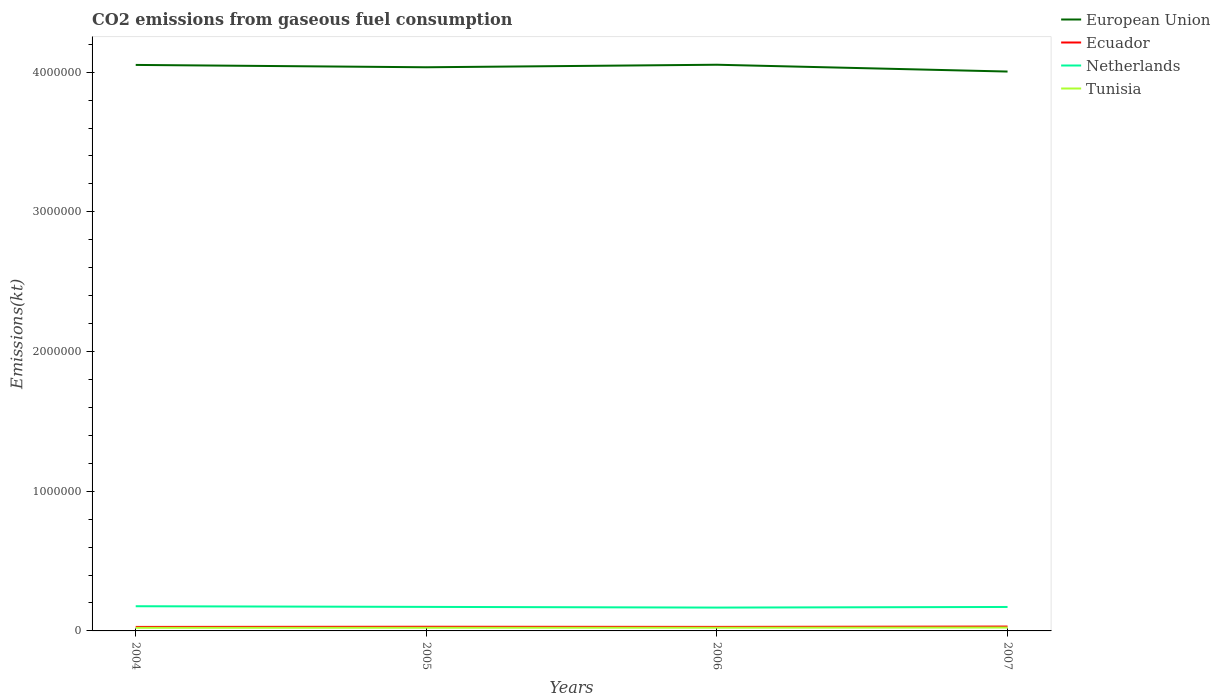How many different coloured lines are there?
Offer a terse response. 4. Across all years, what is the maximum amount of CO2 emitted in Netherlands?
Your answer should be compact. 1.67e+05. In which year was the amount of CO2 emitted in European Union maximum?
Your answer should be compact. 2007. What is the total amount of CO2 emitted in European Union in the graph?
Ensure brevity in your answer.  -1.81e+04. What is the difference between the highest and the second highest amount of CO2 emitted in Ecuador?
Make the answer very short. 2651.24. How many lines are there?
Keep it short and to the point. 4. How many years are there in the graph?
Provide a succinct answer. 4. What is the difference between two consecutive major ticks on the Y-axis?
Offer a very short reply. 1.00e+06. Where does the legend appear in the graph?
Ensure brevity in your answer.  Top right. How many legend labels are there?
Your response must be concise. 4. How are the legend labels stacked?
Keep it short and to the point. Vertical. What is the title of the graph?
Offer a terse response. CO2 emissions from gaseous fuel consumption. What is the label or title of the X-axis?
Keep it short and to the point. Years. What is the label or title of the Y-axis?
Keep it short and to the point. Emissions(kt). What is the Emissions(kt) in European Union in 2004?
Offer a terse response. 4.05e+06. What is the Emissions(kt) of Ecuador in 2004?
Offer a very short reply. 2.87e+04. What is the Emissions(kt) in Netherlands in 2004?
Offer a very short reply. 1.77e+05. What is the Emissions(kt) in Tunisia in 2004?
Your response must be concise. 2.23e+04. What is the Emissions(kt) in European Union in 2005?
Provide a succinct answer. 4.03e+06. What is the Emissions(kt) of Ecuador in 2005?
Offer a terse response. 2.99e+04. What is the Emissions(kt) in Netherlands in 2005?
Your answer should be very brief. 1.72e+05. What is the Emissions(kt) of Tunisia in 2005?
Your answer should be compact. 2.27e+04. What is the Emissions(kt) of European Union in 2006?
Your answer should be compact. 4.05e+06. What is the Emissions(kt) of Ecuador in 2006?
Provide a succinct answer. 2.89e+04. What is the Emissions(kt) of Netherlands in 2006?
Ensure brevity in your answer.  1.67e+05. What is the Emissions(kt) of Tunisia in 2006?
Make the answer very short. 2.30e+04. What is the Emissions(kt) in European Union in 2007?
Keep it short and to the point. 4.00e+06. What is the Emissions(kt) of Ecuador in 2007?
Provide a succinct answer. 3.13e+04. What is the Emissions(kt) in Netherlands in 2007?
Give a very brief answer. 1.71e+05. What is the Emissions(kt) in Tunisia in 2007?
Make the answer very short. 2.41e+04. Across all years, what is the maximum Emissions(kt) of European Union?
Provide a short and direct response. 4.05e+06. Across all years, what is the maximum Emissions(kt) of Ecuador?
Your answer should be compact. 3.13e+04. Across all years, what is the maximum Emissions(kt) of Netherlands?
Ensure brevity in your answer.  1.77e+05. Across all years, what is the maximum Emissions(kt) of Tunisia?
Ensure brevity in your answer.  2.41e+04. Across all years, what is the minimum Emissions(kt) of European Union?
Keep it short and to the point. 4.00e+06. Across all years, what is the minimum Emissions(kt) in Ecuador?
Offer a terse response. 2.87e+04. Across all years, what is the minimum Emissions(kt) of Netherlands?
Your answer should be compact. 1.67e+05. Across all years, what is the minimum Emissions(kt) of Tunisia?
Make the answer very short. 2.23e+04. What is the total Emissions(kt) of European Union in the graph?
Your answer should be very brief. 1.61e+07. What is the total Emissions(kt) in Ecuador in the graph?
Keep it short and to the point. 1.19e+05. What is the total Emissions(kt) in Netherlands in the graph?
Your response must be concise. 6.87e+05. What is the total Emissions(kt) in Tunisia in the graph?
Your response must be concise. 9.21e+04. What is the difference between the Emissions(kt) in European Union in 2004 and that in 2005?
Offer a terse response. 1.68e+04. What is the difference between the Emissions(kt) in Ecuador in 2004 and that in 2005?
Provide a short and direct response. -1250.45. What is the difference between the Emissions(kt) of Netherlands in 2004 and that in 2005?
Provide a succinct answer. 4668.09. What is the difference between the Emissions(kt) in Tunisia in 2004 and that in 2005?
Provide a succinct answer. -363.03. What is the difference between the Emissions(kt) in European Union in 2004 and that in 2006?
Ensure brevity in your answer.  -1342.12. What is the difference between the Emissions(kt) of Ecuador in 2004 and that in 2006?
Make the answer very short. -201.69. What is the difference between the Emissions(kt) in Netherlands in 2004 and that in 2006?
Provide a succinct answer. 9581.87. What is the difference between the Emissions(kt) in Tunisia in 2004 and that in 2006?
Give a very brief answer. -693.06. What is the difference between the Emissions(kt) in European Union in 2004 and that in 2007?
Provide a succinct answer. 4.74e+04. What is the difference between the Emissions(kt) in Ecuador in 2004 and that in 2007?
Keep it short and to the point. -2651.24. What is the difference between the Emissions(kt) of Netherlands in 2004 and that in 2007?
Give a very brief answer. 5199.81. What is the difference between the Emissions(kt) of Tunisia in 2004 and that in 2007?
Make the answer very short. -1811.5. What is the difference between the Emissions(kt) in European Union in 2005 and that in 2006?
Offer a terse response. -1.81e+04. What is the difference between the Emissions(kt) in Ecuador in 2005 and that in 2006?
Your answer should be compact. 1048.76. What is the difference between the Emissions(kt) of Netherlands in 2005 and that in 2006?
Offer a terse response. 4913.78. What is the difference between the Emissions(kt) of Tunisia in 2005 and that in 2006?
Provide a short and direct response. -330.03. What is the difference between the Emissions(kt) of European Union in 2005 and that in 2007?
Offer a terse response. 3.06e+04. What is the difference between the Emissions(kt) of Ecuador in 2005 and that in 2007?
Keep it short and to the point. -1400.79. What is the difference between the Emissions(kt) of Netherlands in 2005 and that in 2007?
Offer a very short reply. 531.72. What is the difference between the Emissions(kt) in Tunisia in 2005 and that in 2007?
Offer a terse response. -1448.46. What is the difference between the Emissions(kt) of European Union in 2006 and that in 2007?
Make the answer very short. 4.88e+04. What is the difference between the Emissions(kt) of Ecuador in 2006 and that in 2007?
Your answer should be very brief. -2449.56. What is the difference between the Emissions(kt) in Netherlands in 2006 and that in 2007?
Provide a short and direct response. -4382.06. What is the difference between the Emissions(kt) of Tunisia in 2006 and that in 2007?
Give a very brief answer. -1118.43. What is the difference between the Emissions(kt) in European Union in 2004 and the Emissions(kt) in Ecuador in 2005?
Make the answer very short. 4.02e+06. What is the difference between the Emissions(kt) in European Union in 2004 and the Emissions(kt) in Netherlands in 2005?
Give a very brief answer. 3.88e+06. What is the difference between the Emissions(kt) in European Union in 2004 and the Emissions(kt) in Tunisia in 2005?
Ensure brevity in your answer.  4.03e+06. What is the difference between the Emissions(kt) of Ecuador in 2004 and the Emissions(kt) of Netherlands in 2005?
Keep it short and to the point. -1.43e+05. What is the difference between the Emissions(kt) of Ecuador in 2004 and the Emissions(kt) of Tunisia in 2005?
Provide a short and direct response. 5995.55. What is the difference between the Emissions(kt) in Netherlands in 2004 and the Emissions(kt) in Tunisia in 2005?
Ensure brevity in your answer.  1.54e+05. What is the difference between the Emissions(kt) of European Union in 2004 and the Emissions(kt) of Ecuador in 2006?
Provide a succinct answer. 4.02e+06. What is the difference between the Emissions(kt) in European Union in 2004 and the Emissions(kt) in Netherlands in 2006?
Provide a short and direct response. 3.88e+06. What is the difference between the Emissions(kt) in European Union in 2004 and the Emissions(kt) in Tunisia in 2006?
Your answer should be very brief. 4.03e+06. What is the difference between the Emissions(kt) in Ecuador in 2004 and the Emissions(kt) in Netherlands in 2006?
Your answer should be very brief. -1.38e+05. What is the difference between the Emissions(kt) of Ecuador in 2004 and the Emissions(kt) of Tunisia in 2006?
Offer a terse response. 5665.52. What is the difference between the Emissions(kt) of Netherlands in 2004 and the Emissions(kt) of Tunisia in 2006?
Make the answer very short. 1.54e+05. What is the difference between the Emissions(kt) in European Union in 2004 and the Emissions(kt) in Ecuador in 2007?
Offer a very short reply. 4.02e+06. What is the difference between the Emissions(kt) in European Union in 2004 and the Emissions(kt) in Netherlands in 2007?
Your answer should be compact. 3.88e+06. What is the difference between the Emissions(kt) of European Union in 2004 and the Emissions(kt) of Tunisia in 2007?
Make the answer very short. 4.03e+06. What is the difference between the Emissions(kt) of Ecuador in 2004 and the Emissions(kt) of Netherlands in 2007?
Your response must be concise. -1.43e+05. What is the difference between the Emissions(kt) of Ecuador in 2004 and the Emissions(kt) of Tunisia in 2007?
Give a very brief answer. 4547.08. What is the difference between the Emissions(kt) of Netherlands in 2004 and the Emissions(kt) of Tunisia in 2007?
Keep it short and to the point. 1.53e+05. What is the difference between the Emissions(kt) in European Union in 2005 and the Emissions(kt) in Ecuador in 2006?
Provide a short and direct response. 4.01e+06. What is the difference between the Emissions(kt) of European Union in 2005 and the Emissions(kt) of Netherlands in 2006?
Keep it short and to the point. 3.87e+06. What is the difference between the Emissions(kt) of European Union in 2005 and the Emissions(kt) of Tunisia in 2006?
Keep it short and to the point. 4.01e+06. What is the difference between the Emissions(kt) in Ecuador in 2005 and the Emissions(kt) in Netherlands in 2006?
Your response must be concise. -1.37e+05. What is the difference between the Emissions(kt) in Ecuador in 2005 and the Emissions(kt) in Tunisia in 2006?
Provide a succinct answer. 6915.96. What is the difference between the Emissions(kt) of Netherlands in 2005 and the Emissions(kt) of Tunisia in 2006?
Keep it short and to the point. 1.49e+05. What is the difference between the Emissions(kt) in European Union in 2005 and the Emissions(kt) in Ecuador in 2007?
Provide a short and direct response. 4.00e+06. What is the difference between the Emissions(kt) of European Union in 2005 and the Emissions(kt) of Netherlands in 2007?
Your response must be concise. 3.86e+06. What is the difference between the Emissions(kt) of European Union in 2005 and the Emissions(kt) of Tunisia in 2007?
Offer a very short reply. 4.01e+06. What is the difference between the Emissions(kt) of Ecuador in 2005 and the Emissions(kt) of Netherlands in 2007?
Your answer should be compact. -1.42e+05. What is the difference between the Emissions(kt) in Ecuador in 2005 and the Emissions(kt) in Tunisia in 2007?
Ensure brevity in your answer.  5797.53. What is the difference between the Emissions(kt) of Netherlands in 2005 and the Emissions(kt) of Tunisia in 2007?
Offer a terse response. 1.48e+05. What is the difference between the Emissions(kt) in European Union in 2006 and the Emissions(kt) in Ecuador in 2007?
Offer a very short reply. 4.02e+06. What is the difference between the Emissions(kt) in European Union in 2006 and the Emissions(kt) in Netherlands in 2007?
Your answer should be compact. 3.88e+06. What is the difference between the Emissions(kt) in European Union in 2006 and the Emissions(kt) in Tunisia in 2007?
Provide a short and direct response. 4.03e+06. What is the difference between the Emissions(kt) of Ecuador in 2006 and the Emissions(kt) of Netherlands in 2007?
Your answer should be compact. -1.43e+05. What is the difference between the Emissions(kt) of Ecuador in 2006 and the Emissions(kt) of Tunisia in 2007?
Give a very brief answer. 4748.77. What is the difference between the Emissions(kt) in Netherlands in 2006 and the Emissions(kt) in Tunisia in 2007?
Give a very brief answer. 1.43e+05. What is the average Emissions(kt) in European Union per year?
Keep it short and to the point. 4.04e+06. What is the average Emissions(kt) in Ecuador per year?
Make the answer very short. 2.97e+04. What is the average Emissions(kt) of Netherlands per year?
Give a very brief answer. 1.72e+05. What is the average Emissions(kt) of Tunisia per year?
Your answer should be compact. 2.30e+04. In the year 2004, what is the difference between the Emissions(kt) in European Union and Emissions(kt) in Ecuador?
Your answer should be compact. 4.02e+06. In the year 2004, what is the difference between the Emissions(kt) in European Union and Emissions(kt) in Netherlands?
Your response must be concise. 3.88e+06. In the year 2004, what is the difference between the Emissions(kt) of European Union and Emissions(kt) of Tunisia?
Offer a terse response. 4.03e+06. In the year 2004, what is the difference between the Emissions(kt) of Ecuador and Emissions(kt) of Netherlands?
Offer a very short reply. -1.48e+05. In the year 2004, what is the difference between the Emissions(kt) in Ecuador and Emissions(kt) in Tunisia?
Ensure brevity in your answer.  6358.58. In the year 2004, what is the difference between the Emissions(kt) of Netherlands and Emissions(kt) of Tunisia?
Ensure brevity in your answer.  1.54e+05. In the year 2005, what is the difference between the Emissions(kt) in European Union and Emissions(kt) in Ecuador?
Your response must be concise. 4.01e+06. In the year 2005, what is the difference between the Emissions(kt) of European Union and Emissions(kt) of Netherlands?
Your answer should be very brief. 3.86e+06. In the year 2005, what is the difference between the Emissions(kt) of European Union and Emissions(kt) of Tunisia?
Make the answer very short. 4.01e+06. In the year 2005, what is the difference between the Emissions(kt) in Ecuador and Emissions(kt) in Netherlands?
Ensure brevity in your answer.  -1.42e+05. In the year 2005, what is the difference between the Emissions(kt) of Ecuador and Emissions(kt) of Tunisia?
Provide a succinct answer. 7245.99. In the year 2005, what is the difference between the Emissions(kt) in Netherlands and Emissions(kt) in Tunisia?
Your answer should be very brief. 1.49e+05. In the year 2006, what is the difference between the Emissions(kt) of European Union and Emissions(kt) of Ecuador?
Ensure brevity in your answer.  4.02e+06. In the year 2006, what is the difference between the Emissions(kt) in European Union and Emissions(kt) in Netherlands?
Provide a short and direct response. 3.89e+06. In the year 2006, what is the difference between the Emissions(kt) in European Union and Emissions(kt) in Tunisia?
Keep it short and to the point. 4.03e+06. In the year 2006, what is the difference between the Emissions(kt) in Ecuador and Emissions(kt) in Netherlands?
Ensure brevity in your answer.  -1.38e+05. In the year 2006, what is the difference between the Emissions(kt) of Ecuador and Emissions(kt) of Tunisia?
Ensure brevity in your answer.  5867.2. In the year 2006, what is the difference between the Emissions(kt) of Netherlands and Emissions(kt) of Tunisia?
Provide a succinct answer. 1.44e+05. In the year 2007, what is the difference between the Emissions(kt) of European Union and Emissions(kt) of Ecuador?
Offer a very short reply. 3.97e+06. In the year 2007, what is the difference between the Emissions(kt) in European Union and Emissions(kt) in Netherlands?
Make the answer very short. 3.83e+06. In the year 2007, what is the difference between the Emissions(kt) of European Union and Emissions(kt) of Tunisia?
Offer a terse response. 3.98e+06. In the year 2007, what is the difference between the Emissions(kt) in Ecuador and Emissions(kt) in Netherlands?
Offer a very short reply. -1.40e+05. In the year 2007, what is the difference between the Emissions(kt) in Ecuador and Emissions(kt) in Tunisia?
Give a very brief answer. 7198.32. In the year 2007, what is the difference between the Emissions(kt) of Netherlands and Emissions(kt) of Tunisia?
Your answer should be compact. 1.47e+05. What is the ratio of the Emissions(kt) of European Union in 2004 to that in 2005?
Offer a very short reply. 1. What is the ratio of the Emissions(kt) in Ecuador in 2004 to that in 2005?
Give a very brief answer. 0.96. What is the ratio of the Emissions(kt) in Netherlands in 2004 to that in 2005?
Ensure brevity in your answer.  1.03. What is the ratio of the Emissions(kt) in Netherlands in 2004 to that in 2006?
Your answer should be very brief. 1.06. What is the ratio of the Emissions(kt) of Tunisia in 2004 to that in 2006?
Provide a short and direct response. 0.97. What is the ratio of the Emissions(kt) in European Union in 2004 to that in 2007?
Provide a succinct answer. 1.01. What is the ratio of the Emissions(kt) of Ecuador in 2004 to that in 2007?
Offer a terse response. 0.92. What is the ratio of the Emissions(kt) of Netherlands in 2004 to that in 2007?
Give a very brief answer. 1.03. What is the ratio of the Emissions(kt) of Tunisia in 2004 to that in 2007?
Offer a terse response. 0.92. What is the ratio of the Emissions(kt) in European Union in 2005 to that in 2006?
Offer a terse response. 1. What is the ratio of the Emissions(kt) of Ecuador in 2005 to that in 2006?
Your answer should be compact. 1.04. What is the ratio of the Emissions(kt) in Netherlands in 2005 to that in 2006?
Keep it short and to the point. 1.03. What is the ratio of the Emissions(kt) of Tunisia in 2005 to that in 2006?
Give a very brief answer. 0.99. What is the ratio of the Emissions(kt) in European Union in 2005 to that in 2007?
Ensure brevity in your answer.  1.01. What is the ratio of the Emissions(kt) of Ecuador in 2005 to that in 2007?
Keep it short and to the point. 0.96. What is the ratio of the Emissions(kt) in Netherlands in 2005 to that in 2007?
Provide a succinct answer. 1. What is the ratio of the Emissions(kt) in Tunisia in 2005 to that in 2007?
Your answer should be compact. 0.94. What is the ratio of the Emissions(kt) of European Union in 2006 to that in 2007?
Offer a terse response. 1.01. What is the ratio of the Emissions(kt) of Ecuador in 2006 to that in 2007?
Keep it short and to the point. 0.92. What is the ratio of the Emissions(kt) of Netherlands in 2006 to that in 2007?
Offer a terse response. 0.97. What is the ratio of the Emissions(kt) in Tunisia in 2006 to that in 2007?
Provide a succinct answer. 0.95. What is the difference between the highest and the second highest Emissions(kt) of European Union?
Your response must be concise. 1342.12. What is the difference between the highest and the second highest Emissions(kt) in Ecuador?
Your answer should be very brief. 1400.79. What is the difference between the highest and the second highest Emissions(kt) in Netherlands?
Make the answer very short. 4668.09. What is the difference between the highest and the second highest Emissions(kt) in Tunisia?
Make the answer very short. 1118.43. What is the difference between the highest and the lowest Emissions(kt) of European Union?
Offer a very short reply. 4.88e+04. What is the difference between the highest and the lowest Emissions(kt) of Ecuador?
Ensure brevity in your answer.  2651.24. What is the difference between the highest and the lowest Emissions(kt) of Netherlands?
Offer a terse response. 9581.87. What is the difference between the highest and the lowest Emissions(kt) in Tunisia?
Offer a very short reply. 1811.5. 